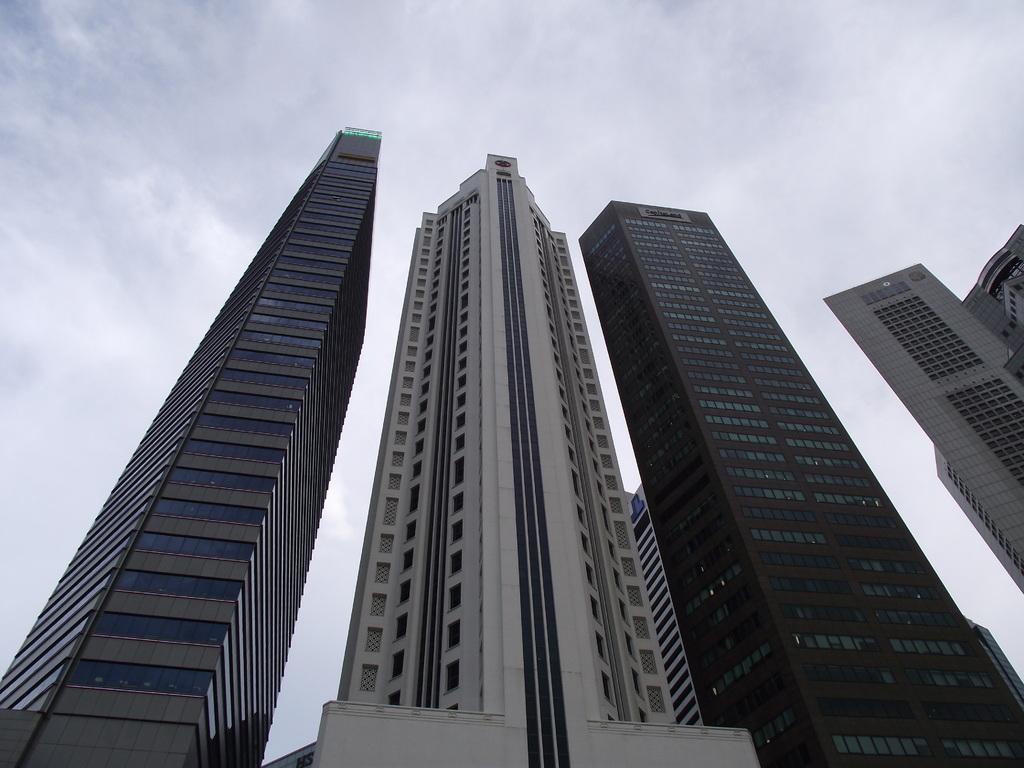What type of structures can be seen in the image? There are buildings in the image. What part of the natural environment is visible in the image? The sky is visible in the image. How many guitars can be seen hanging on the walls of the buildings in the image? There are no guitars visible in the image; only buildings and the sky are present. Are there any bears visible in the image? There are no bears present in the image. 